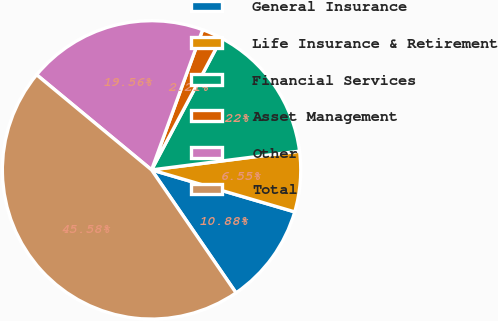Convert chart to OTSL. <chart><loc_0><loc_0><loc_500><loc_500><pie_chart><fcel>General Insurance<fcel>Life Insurance & Retirement<fcel>Financial Services<fcel>Asset Management<fcel>Other<fcel>Total<nl><fcel>10.88%<fcel>6.55%<fcel>15.22%<fcel>2.21%<fcel>19.56%<fcel>45.58%<nl></chart> 